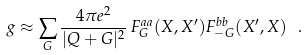Convert formula to latex. <formula><loc_0><loc_0><loc_500><loc_500>g \approx \sum _ { G } \frac { 4 \pi e ^ { 2 } } { | Q + G | ^ { 2 } } \, F ^ { a a } _ { G } ( X , X ^ { \prime } ) F ^ { b b } _ { - G } ( X ^ { \prime } , X ) \ .</formula> 